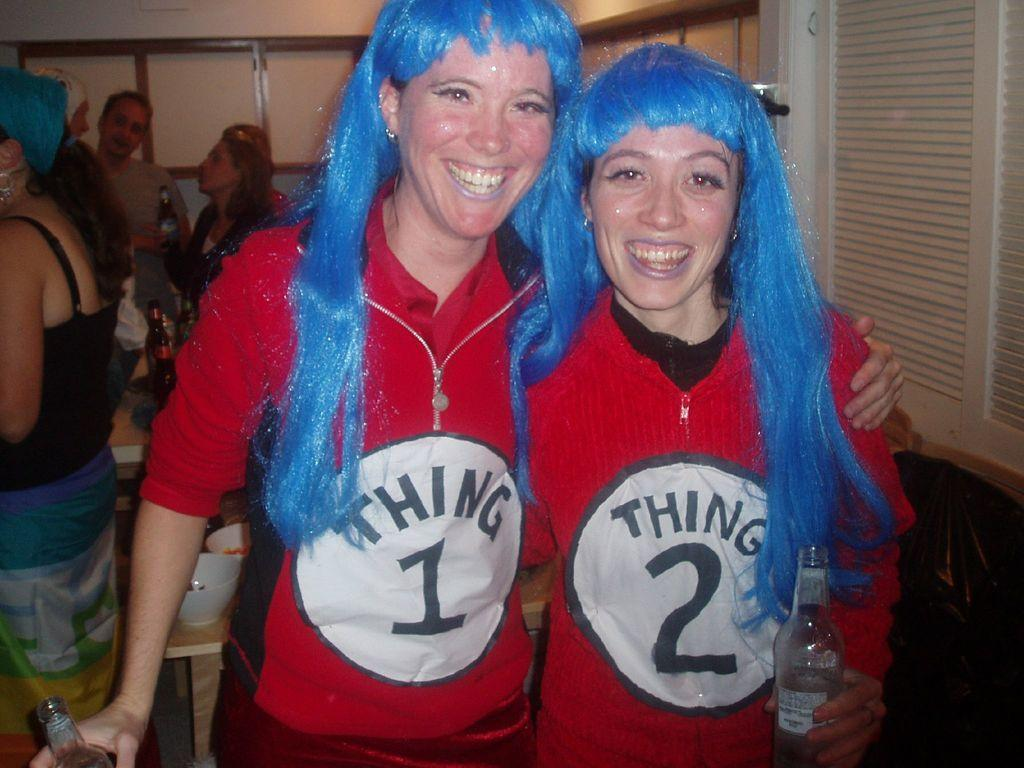<image>
Give a short and clear explanation of the subsequent image. Two people wearing red shirts with circles inscribed with the word THING 